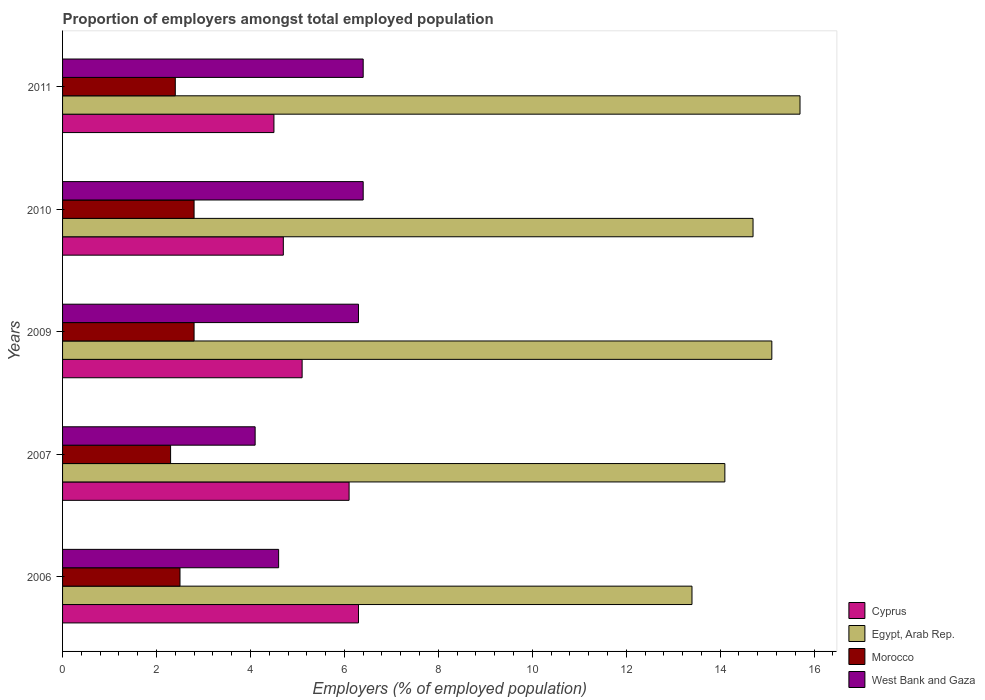How many different coloured bars are there?
Give a very brief answer. 4. Are the number of bars per tick equal to the number of legend labels?
Your response must be concise. Yes. How many bars are there on the 1st tick from the top?
Your answer should be very brief. 4. What is the label of the 5th group of bars from the top?
Ensure brevity in your answer.  2006. In how many cases, is the number of bars for a given year not equal to the number of legend labels?
Give a very brief answer. 0. What is the proportion of employers in West Bank and Gaza in 2009?
Your response must be concise. 6.3. Across all years, what is the maximum proportion of employers in Cyprus?
Provide a succinct answer. 6.3. Across all years, what is the minimum proportion of employers in Egypt, Arab Rep.?
Keep it short and to the point. 13.4. What is the total proportion of employers in Morocco in the graph?
Make the answer very short. 12.8. What is the difference between the proportion of employers in Cyprus in 2009 and that in 2010?
Offer a terse response. 0.4. What is the difference between the proportion of employers in West Bank and Gaza in 2010 and the proportion of employers in Cyprus in 2007?
Provide a succinct answer. 0.3. What is the average proportion of employers in Cyprus per year?
Provide a short and direct response. 5.34. In the year 2010, what is the difference between the proportion of employers in West Bank and Gaza and proportion of employers in Morocco?
Your answer should be very brief. 3.6. In how many years, is the proportion of employers in Morocco greater than 6 %?
Make the answer very short. 0. What is the ratio of the proportion of employers in Morocco in 2007 to that in 2011?
Your answer should be compact. 0.96. Is the proportion of employers in Morocco in 2007 less than that in 2010?
Provide a short and direct response. Yes. Is the difference between the proportion of employers in West Bank and Gaza in 2009 and 2011 greater than the difference between the proportion of employers in Morocco in 2009 and 2011?
Offer a very short reply. No. What is the difference between the highest and the second highest proportion of employers in Egypt, Arab Rep.?
Make the answer very short. 0.6. What is the difference between the highest and the lowest proportion of employers in Cyprus?
Provide a short and direct response. 1.8. Is the sum of the proportion of employers in Egypt, Arab Rep. in 2006 and 2011 greater than the maximum proportion of employers in Morocco across all years?
Provide a succinct answer. Yes. What does the 4th bar from the top in 2006 represents?
Keep it short and to the point. Cyprus. What does the 3rd bar from the bottom in 2011 represents?
Make the answer very short. Morocco. How many years are there in the graph?
Your answer should be compact. 5. What is the difference between two consecutive major ticks on the X-axis?
Your answer should be very brief. 2. Are the values on the major ticks of X-axis written in scientific E-notation?
Your response must be concise. No. Does the graph contain grids?
Your answer should be compact. No. Where does the legend appear in the graph?
Your answer should be very brief. Bottom right. How many legend labels are there?
Provide a short and direct response. 4. What is the title of the graph?
Keep it short and to the point. Proportion of employers amongst total employed population. What is the label or title of the X-axis?
Your answer should be compact. Employers (% of employed population). What is the label or title of the Y-axis?
Offer a very short reply. Years. What is the Employers (% of employed population) of Cyprus in 2006?
Offer a terse response. 6.3. What is the Employers (% of employed population) of Egypt, Arab Rep. in 2006?
Offer a very short reply. 13.4. What is the Employers (% of employed population) of Morocco in 2006?
Give a very brief answer. 2.5. What is the Employers (% of employed population) of West Bank and Gaza in 2006?
Provide a short and direct response. 4.6. What is the Employers (% of employed population) of Cyprus in 2007?
Keep it short and to the point. 6.1. What is the Employers (% of employed population) in Egypt, Arab Rep. in 2007?
Ensure brevity in your answer.  14.1. What is the Employers (% of employed population) of Morocco in 2007?
Provide a succinct answer. 2.3. What is the Employers (% of employed population) of West Bank and Gaza in 2007?
Offer a terse response. 4.1. What is the Employers (% of employed population) in Cyprus in 2009?
Keep it short and to the point. 5.1. What is the Employers (% of employed population) in Egypt, Arab Rep. in 2009?
Your answer should be compact. 15.1. What is the Employers (% of employed population) of Morocco in 2009?
Your answer should be compact. 2.8. What is the Employers (% of employed population) of West Bank and Gaza in 2009?
Give a very brief answer. 6.3. What is the Employers (% of employed population) in Cyprus in 2010?
Give a very brief answer. 4.7. What is the Employers (% of employed population) of Egypt, Arab Rep. in 2010?
Ensure brevity in your answer.  14.7. What is the Employers (% of employed population) in Morocco in 2010?
Provide a short and direct response. 2.8. What is the Employers (% of employed population) in West Bank and Gaza in 2010?
Keep it short and to the point. 6.4. What is the Employers (% of employed population) of Egypt, Arab Rep. in 2011?
Provide a succinct answer. 15.7. What is the Employers (% of employed population) of Morocco in 2011?
Provide a succinct answer. 2.4. What is the Employers (% of employed population) of West Bank and Gaza in 2011?
Your answer should be compact. 6.4. Across all years, what is the maximum Employers (% of employed population) of Cyprus?
Your answer should be compact. 6.3. Across all years, what is the maximum Employers (% of employed population) in Egypt, Arab Rep.?
Provide a short and direct response. 15.7. Across all years, what is the maximum Employers (% of employed population) in Morocco?
Make the answer very short. 2.8. Across all years, what is the maximum Employers (% of employed population) in West Bank and Gaza?
Your answer should be very brief. 6.4. Across all years, what is the minimum Employers (% of employed population) in Cyprus?
Give a very brief answer. 4.5. Across all years, what is the minimum Employers (% of employed population) in Egypt, Arab Rep.?
Provide a succinct answer. 13.4. Across all years, what is the minimum Employers (% of employed population) of Morocco?
Your answer should be compact. 2.3. Across all years, what is the minimum Employers (% of employed population) of West Bank and Gaza?
Provide a succinct answer. 4.1. What is the total Employers (% of employed population) in Cyprus in the graph?
Give a very brief answer. 26.7. What is the total Employers (% of employed population) of Egypt, Arab Rep. in the graph?
Offer a very short reply. 73. What is the total Employers (% of employed population) in Morocco in the graph?
Keep it short and to the point. 12.8. What is the total Employers (% of employed population) in West Bank and Gaza in the graph?
Ensure brevity in your answer.  27.8. What is the difference between the Employers (% of employed population) in Egypt, Arab Rep. in 2006 and that in 2007?
Keep it short and to the point. -0.7. What is the difference between the Employers (% of employed population) in Morocco in 2006 and that in 2007?
Your response must be concise. 0.2. What is the difference between the Employers (% of employed population) of West Bank and Gaza in 2006 and that in 2007?
Your answer should be compact. 0.5. What is the difference between the Employers (% of employed population) of Cyprus in 2006 and that in 2009?
Give a very brief answer. 1.2. What is the difference between the Employers (% of employed population) in West Bank and Gaza in 2006 and that in 2009?
Keep it short and to the point. -1.7. What is the difference between the Employers (% of employed population) of Cyprus in 2006 and that in 2010?
Make the answer very short. 1.6. What is the difference between the Employers (% of employed population) of West Bank and Gaza in 2006 and that in 2010?
Keep it short and to the point. -1.8. What is the difference between the Employers (% of employed population) in Cyprus in 2006 and that in 2011?
Offer a very short reply. 1.8. What is the difference between the Employers (% of employed population) of Egypt, Arab Rep. in 2006 and that in 2011?
Make the answer very short. -2.3. What is the difference between the Employers (% of employed population) of Morocco in 2007 and that in 2009?
Your response must be concise. -0.5. What is the difference between the Employers (% of employed population) of West Bank and Gaza in 2007 and that in 2009?
Keep it short and to the point. -2.2. What is the difference between the Employers (% of employed population) in Cyprus in 2007 and that in 2010?
Your response must be concise. 1.4. What is the difference between the Employers (% of employed population) in Egypt, Arab Rep. in 2007 and that in 2010?
Your answer should be compact. -0.6. What is the difference between the Employers (% of employed population) in Egypt, Arab Rep. in 2007 and that in 2011?
Ensure brevity in your answer.  -1.6. What is the difference between the Employers (% of employed population) of West Bank and Gaza in 2007 and that in 2011?
Make the answer very short. -2.3. What is the difference between the Employers (% of employed population) of Cyprus in 2009 and that in 2010?
Offer a very short reply. 0.4. What is the difference between the Employers (% of employed population) of Egypt, Arab Rep. in 2009 and that in 2010?
Provide a succinct answer. 0.4. What is the difference between the Employers (% of employed population) in Egypt, Arab Rep. in 2009 and that in 2011?
Give a very brief answer. -0.6. What is the difference between the Employers (% of employed population) of Morocco in 2009 and that in 2011?
Your answer should be very brief. 0.4. What is the difference between the Employers (% of employed population) of West Bank and Gaza in 2009 and that in 2011?
Make the answer very short. -0.1. What is the difference between the Employers (% of employed population) of Cyprus in 2010 and that in 2011?
Offer a very short reply. 0.2. What is the difference between the Employers (% of employed population) in Morocco in 2010 and that in 2011?
Your answer should be compact. 0.4. What is the difference between the Employers (% of employed population) in Cyprus in 2006 and the Employers (% of employed population) in Morocco in 2007?
Offer a very short reply. 4. What is the difference between the Employers (% of employed population) in Egypt, Arab Rep. in 2006 and the Employers (% of employed population) in Morocco in 2007?
Make the answer very short. 11.1. What is the difference between the Employers (% of employed population) in Egypt, Arab Rep. in 2006 and the Employers (% of employed population) in West Bank and Gaza in 2007?
Your answer should be very brief. 9.3. What is the difference between the Employers (% of employed population) of Cyprus in 2006 and the Employers (% of employed population) of Egypt, Arab Rep. in 2009?
Ensure brevity in your answer.  -8.8. What is the difference between the Employers (% of employed population) in Cyprus in 2006 and the Employers (% of employed population) in Morocco in 2009?
Ensure brevity in your answer.  3.5. What is the difference between the Employers (% of employed population) of Cyprus in 2006 and the Employers (% of employed population) of West Bank and Gaza in 2009?
Provide a short and direct response. 0. What is the difference between the Employers (% of employed population) of Cyprus in 2006 and the Employers (% of employed population) of Morocco in 2010?
Keep it short and to the point. 3.5. What is the difference between the Employers (% of employed population) of Cyprus in 2006 and the Employers (% of employed population) of West Bank and Gaza in 2010?
Give a very brief answer. -0.1. What is the difference between the Employers (% of employed population) in Cyprus in 2006 and the Employers (% of employed population) in West Bank and Gaza in 2011?
Offer a very short reply. -0.1. What is the difference between the Employers (% of employed population) in Morocco in 2006 and the Employers (% of employed population) in West Bank and Gaza in 2011?
Provide a succinct answer. -3.9. What is the difference between the Employers (% of employed population) of Cyprus in 2007 and the Employers (% of employed population) of Egypt, Arab Rep. in 2009?
Offer a very short reply. -9. What is the difference between the Employers (% of employed population) of Cyprus in 2007 and the Employers (% of employed population) of West Bank and Gaza in 2009?
Your response must be concise. -0.2. What is the difference between the Employers (% of employed population) of Egypt, Arab Rep. in 2007 and the Employers (% of employed population) of Morocco in 2009?
Your answer should be very brief. 11.3. What is the difference between the Employers (% of employed population) in Cyprus in 2007 and the Employers (% of employed population) in Egypt, Arab Rep. in 2010?
Offer a terse response. -8.6. What is the difference between the Employers (% of employed population) of Cyprus in 2007 and the Employers (% of employed population) of Morocco in 2010?
Offer a terse response. 3.3. What is the difference between the Employers (% of employed population) in Cyprus in 2007 and the Employers (% of employed population) in West Bank and Gaza in 2010?
Provide a succinct answer. -0.3. What is the difference between the Employers (% of employed population) in Morocco in 2007 and the Employers (% of employed population) in West Bank and Gaza in 2010?
Your answer should be very brief. -4.1. What is the difference between the Employers (% of employed population) in Cyprus in 2007 and the Employers (% of employed population) in Morocco in 2011?
Your answer should be compact. 3.7. What is the difference between the Employers (% of employed population) of Cyprus in 2007 and the Employers (% of employed population) of West Bank and Gaza in 2011?
Make the answer very short. -0.3. What is the difference between the Employers (% of employed population) in Egypt, Arab Rep. in 2009 and the Employers (% of employed population) in Morocco in 2010?
Your response must be concise. 12.3. What is the difference between the Employers (% of employed population) in Morocco in 2009 and the Employers (% of employed population) in West Bank and Gaza in 2010?
Your response must be concise. -3.6. What is the difference between the Employers (% of employed population) of Cyprus in 2009 and the Employers (% of employed population) of West Bank and Gaza in 2011?
Offer a very short reply. -1.3. What is the difference between the Employers (% of employed population) of Egypt, Arab Rep. in 2009 and the Employers (% of employed population) of Morocco in 2011?
Ensure brevity in your answer.  12.7. What is the difference between the Employers (% of employed population) in Morocco in 2009 and the Employers (% of employed population) in West Bank and Gaza in 2011?
Provide a short and direct response. -3.6. What is the difference between the Employers (% of employed population) of Cyprus in 2010 and the Employers (% of employed population) of West Bank and Gaza in 2011?
Ensure brevity in your answer.  -1.7. What is the difference between the Employers (% of employed population) in Egypt, Arab Rep. in 2010 and the Employers (% of employed population) in West Bank and Gaza in 2011?
Ensure brevity in your answer.  8.3. What is the difference between the Employers (% of employed population) of Morocco in 2010 and the Employers (% of employed population) of West Bank and Gaza in 2011?
Offer a very short reply. -3.6. What is the average Employers (% of employed population) in Cyprus per year?
Your answer should be very brief. 5.34. What is the average Employers (% of employed population) in Egypt, Arab Rep. per year?
Give a very brief answer. 14.6. What is the average Employers (% of employed population) of Morocco per year?
Keep it short and to the point. 2.56. What is the average Employers (% of employed population) of West Bank and Gaza per year?
Offer a very short reply. 5.56. In the year 2006, what is the difference between the Employers (% of employed population) of Cyprus and Employers (% of employed population) of West Bank and Gaza?
Your response must be concise. 1.7. In the year 2006, what is the difference between the Employers (% of employed population) of Morocco and Employers (% of employed population) of West Bank and Gaza?
Offer a terse response. -2.1. In the year 2007, what is the difference between the Employers (% of employed population) of Cyprus and Employers (% of employed population) of Morocco?
Your answer should be very brief. 3.8. In the year 2007, what is the difference between the Employers (% of employed population) of Egypt, Arab Rep. and Employers (% of employed population) of Morocco?
Offer a terse response. 11.8. In the year 2007, what is the difference between the Employers (% of employed population) of Egypt, Arab Rep. and Employers (% of employed population) of West Bank and Gaza?
Offer a very short reply. 10. In the year 2009, what is the difference between the Employers (% of employed population) of Cyprus and Employers (% of employed population) of Egypt, Arab Rep.?
Give a very brief answer. -10. In the year 2009, what is the difference between the Employers (% of employed population) in Cyprus and Employers (% of employed population) in West Bank and Gaza?
Offer a terse response. -1.2. In the year 2009, what is the difference between the Employers (% of employed population) in Egypt, Arab Rep. and Employers (% of employed population) in Morocco?
Ensure brevity in your answer.  12.3. In the year 2009, what is the difference between the Employers (% of employed population) of Egypt, Arab Rep. and Employers (% of employed population) of West Bank and Gaza?
Offer a very short reply. 8.8. In the year 2009, what is the difference between the Employers (% of employed population) in Morocco and Employers (% of employed population) in West Bank and Gaza?
Provide a succinct answer. -3.5. In the year 2010, what is the difference between the Employers (% of employed population) in Morocco and Employers (% of employed population) in West Bank and Gaza?
Give a very brief answer. -3.6. In the year 2011, what is the difference between the Employers (% of employed population) in Cyprus and Employers (% of employed population) in Egypt, Arab Rep.?
Give a very brief answer. -11.2. In the year 2011, what is the difference between the Employers (% of employed population) in Egypt, Arab Rep. and Employers (% of employed population) in Morocco?
Give a very brief answer. 13.3. In the year 2011, what is the difference between the Employers (% of employed population) in Morocco and Employers (% of employed population) in West Bank and Gaza?
Your response must be concise. -4. What is the ratio of the Employers (% of employed population) in Cyprus in 2006 to that in 2007?
Offer a terse response. 1.03. What is the ratio of the Employers (% of employed population) of Egypt, Arab Rep. in 2006 to that in 2007?
Ensure brevity in your answer.  0.95. What is the ratio of the Employers (% of employed population) of Morocco in 2006 to that in 2007?
Provide a succinct answer. 1.09. What is the ratio of the Employers (% of employed population) of West Bank and Gaza in 2006 to that in 2007?
Your response must be concise. 1.12. What is the ratio of the Employers (% of employed population) of Cyprus in 2006 to that in 2009?
Offer a very short reply. 1.24. What is the ratio of the Employers (% of employed population) in Egypt, Arab Rep. in 2006 to that in 2009?
Offer a terse response. 0.89. What is the ratio of the Employers (% of employed population) in Morocco in 2006 to that in 2009?
Provide a succinct answer. 0.89. What is the ratio of the Employers (% of employed population) of West Bank and Gaza in 2006 to that in 2009?
Make the answer very short. 0.73. What is the ratio of the Employers (% of employed population) in Cyprus in 2006 to that in 2010?
Provide a short and direct response. 1.34. What is the ratio of the Employers (% of employed population) in Egypt, Arab Rep. in 2006 to that in 2010?
Your response must be concise. 0.91. What is the ratio of the Employers (% of employed population) of Morocco in 2006 to that in 2010?
Provide a short and direct response. 0.89. What is the ratio of the Employers (% of employed population) in West Bank and Gaza in 2006 to that in 2010?
Your response must be concise. 0.72. What is the ratio of the Employers (% of employed population) in Cyprus in 2006 to that in 2011?
Ensure brevity in your answer.  1.4. What is the ratio of the Employers (% of employed population) in Egypt, Arab Rep. in 2006 to that in 2011?
Your answer should be very brief. 0.85. What is the ratio of the Employers (% of employed population) in Morocco in 2006 to that in 2011?
Your answer should be very brief. 1.04. What is the ratio of the Employers (% of employed population) of West Bank and Gaza in 2006 to that in 2011?
Your answer should be compact. 0.72. What is the ratio of the Employers (% of employed population) in Cyprus in 2007 to that in 2009?
Your response must be concise. 1.2. What is the ratio of the Employers (% of employed population) of Egypt, Arab Rep. in 2007 to that in 2009?
Ensure brevity in your answer.  0.93. What is the ratio of the Employers (% of employed population) in Morocco in 2007 to that in 2009?
Ensure brevity in your answer.  0.82. What is the ratio of the Employers (% of employed population) in West Bank and Gaza in 2007 to that in 2009?
Provide a succinct answer. 0.65. What is the ratio of the Employers (% of employed population) of Cyprus in 2007 to that in 2010?
Give a very brief answer. 1.3. What is the ratio of the Employers (% of employed population) of Egypt, Arab Rep. in 2007 to that in 2010?
Make the answer very short. 0.96. What is the ratio of the Employers (% of employed population) of Morocco in 2007 to that in 2010?
Make the answer very short. 0.82. What is the ratio of the Employers (% of employed population) of West Bank and Gaza in 2007 to that in 2010?
Your answer should be very brief. 0.64. What is the ratio of the Employers (% of employed population) in Cyprus in 2007 to that in 2011?
Give a very brief answer. 1.36. What is the ratio of the Employers (% of employed population) in Egypt, Arab Rep. in 2007 to that in 2011?
Ensure brevity in your answer.  0.9. What is the ratio of the Employers (% of employed population) in West Bank and Gaza in 2007 to that in 2011?
Keep it short and to the point. 0.64. What is the ratio of the Employers (% of employed population) of Cyprus in 2009 to that in 2010?
Your answer should be compact. 1.09. What is the ratio of the Employers (% of employed population) in Egypt, Arab Rep. in 2009 to that in 2010?
Keep it short and to the point. 1.03. What is the ratio of the Employers (% of employed population) of Morocco in 2009 to that in 2010?
Your response must be concise. 1. What is the ratio of the Employers (% of employed population) of West Bank and Gaza in 2009 to that in 2010?
Give a very brief answer. 0.98. What is the ratio of the Employers (% of employed population) of Cyprus in 2009 to that in 2011?
Offer a very short reply. 1.13. What is the ratio of the Employers (% of employed population) in Egypt, Arab Rep. in 2009 to that in 2011?
Your answer should be very brief. 0.96. What is the ratio of the Employers (% of employed population) of Morocco in 2009 to that in 2011?
Make the answer very short. 1.17. What is the ratio of the Employers (% of employed population) in West Bank and Gaza in 2009 to that in 2011?
Provide a short and direct response. 0.98. What is the ratio of the Employers (% of employed population) of Cyprus in 2010 to that in 2011?
Offer a very short reply. 1.04. What is the ratio of the Employers (% of employed population) in Egypt, Arab Rep. in 2010 to that in 2011?
Offer a very short reply. 0.94. What is the ratio of the Employers (% of employed population) in Morocco in 2010 to that in 2011?
Give a very brief answer. 1.17. What is the difference between the highest and the second highest Employers (% of employed population) in Cyprus?
Ensure brevity in your answer.  0.2. What is the difference between the highest and the second highest Employers (% of employed population) in Egypt, Arab Rep.?
Give a very brief answer. 0.6. What is the difference between the highest and the second highest Employers (% of employed population) of Morocco?
Provide a succinct answer. 0. What is the difference between the highest and the second highest Employers (% of employed population) of West Bank and Gaza?
Provide a succinct answer. 0. What is the difference between the highest and the lowest Employers (% of employed population) in Egypt, Arab Rep.?
Give a very brief answer. 2.3. What is the difference between the highest and the lowest Employers (% of employed population) of West Bank and Gaza?
Make the answer very short. 2.3. 